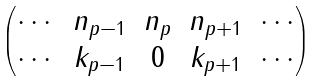<formula> <loc_0><loc_0><loc_500><loc_500>\begin{pmatrix} \cdots & n _ { p - 1 } & n _ { p } & n _ { p + 1 } & \cdots \\ \cdots & k _ { p - 1 } & 0 & k _ { p + 1 } & \cdots \\ \end{pmatrix}</formula> 